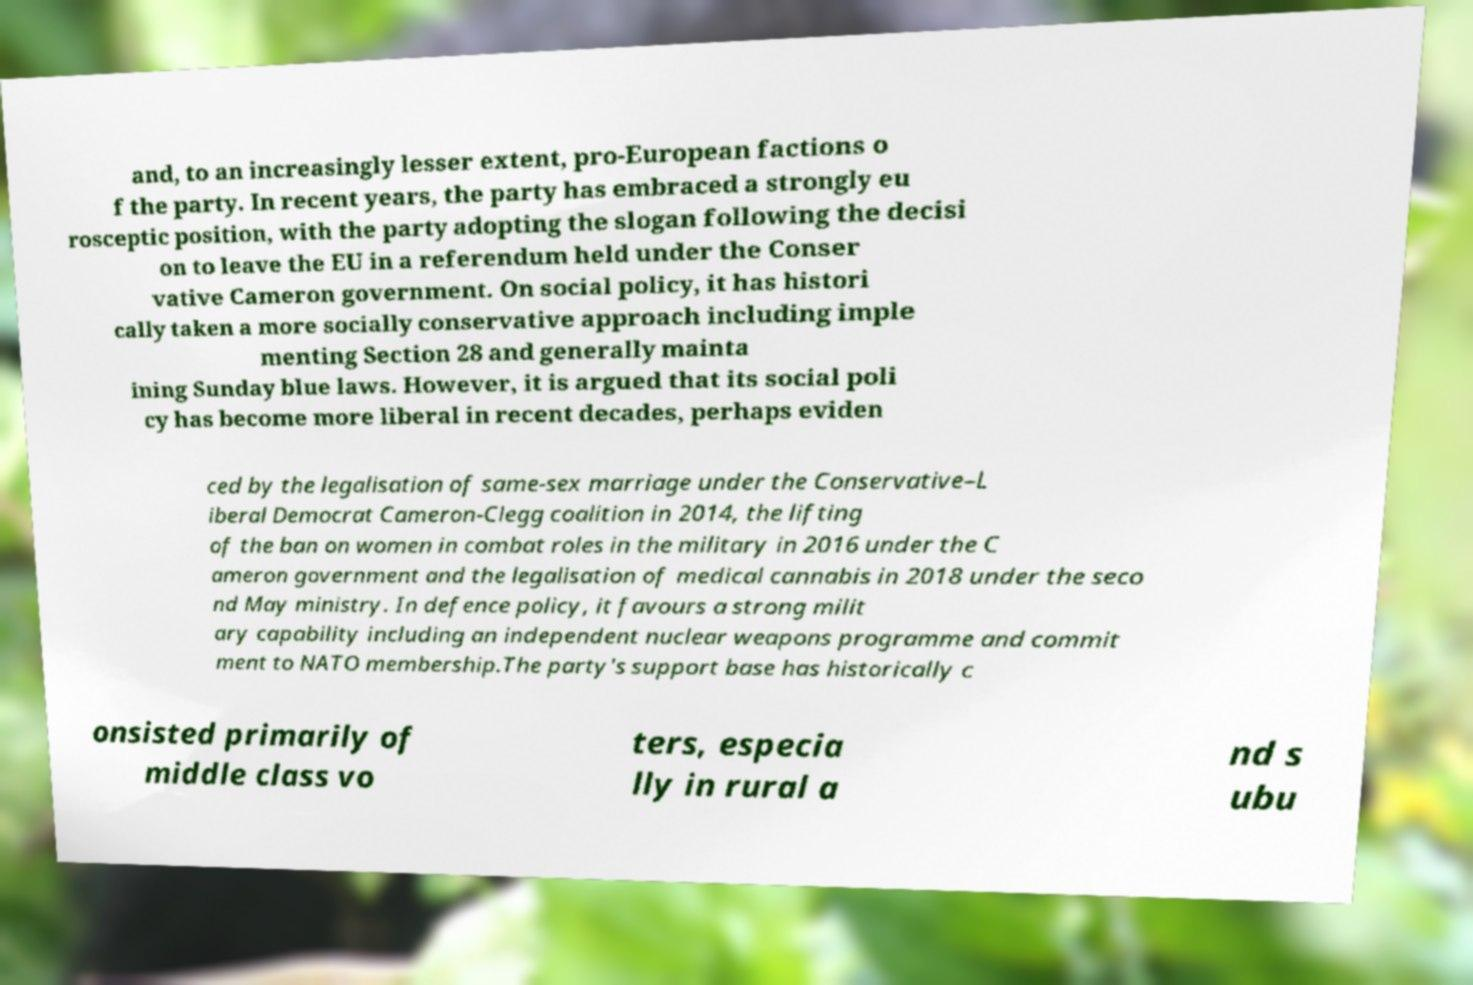Please read and relay the text visible in this image. What does it say? and, to an increasingly lesser extent, pro-European factions o f the party. In recent years, the party has embraced a strongly eu rosceptic position, with the party adopting the slogan following the decisi on to leave the EU in a referendum held under the Conser vative Cameron government. On social policy, it has histori cally taken a more socially conservative approach including imple menting Section 28 and generally mainta ining Sunday blue laws. However, it is argued that its social poli cy has become more liberal in recent decades, perhaps eviden ced by the legalisation of same-sex marriage under the Conservative–L iberal Democrat Cameron-Clegg coalition in 2014, the lifting of the ban on women in combat roles in the military in 2016 under the C ameron government and the legalisation of medical cannabis in 2018 under the seco nd May ministry. In defence policy, it favours a strong milit ary capability including an independent nuclear weapons programme and commit ment to NATO membership.The party's support base has historically c onsisted primarily of middle class vo ters, especia lly in rural a nd s ubu 